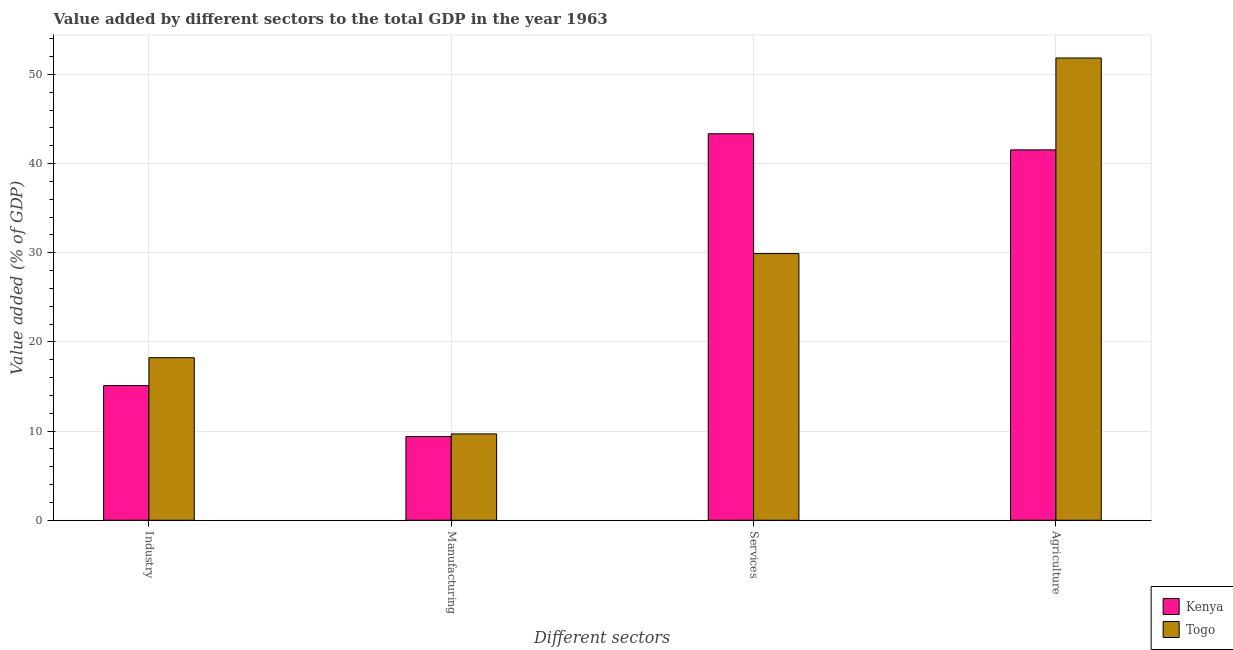Are the number of bars per tick equal to the number of legend labels?
Your answer should be compact. Yes. What is the label of the 4th group of bars from the left?
Ensure brevity in your answer.  Agriculture. What is the value added by manufacturing sector in Kenya?
Give a very brief answer. 9.39. Across all countries, what is the maximum value added by services sector?
Your answer should be very brief. 43.35. Across all countries, what is the minimum value added by industrial sector?
Your answer should be very brief. 15.1. In which country was the value added by manufacturing sector maximum?
Provide a succinct answer. Togo. In which country was the value added by industrial sector minimum?
Your answer should be very brief. Kenya. What is the total value added by services sector in the graph?
Make the answer very short. 73.27. What is the difference between the value added by services sector in Kenya and that in Togo?
Ensure brevity in your answer.  13.44. What is the difference between the value added by manufacturing sector in Kenya and the value added by services sector in Togo?
Make the answer very short. -20.52. What is the average value added by industrial sector per country?
Provide a succinct answer. 16.67. What is the difference between the value added by services sector and value added by agricultural sector in Kenya?
Give a very brief answer. 1.81. In how many countries, is the value added by services sector greater than 48 %?
Your response must be concise. 0. What is the ratio of the value added by industrial sector in Togo to that in Kenya?
Your response must be concise. 1.21. What is the difference between the highest and the second highest value added by agricultural sector?
Offer a very short reply. 10.31. What is the difference between the highest and the lowest value added by agricultural sector?
Your answer should be very brief. 10.31. Is it the case that in every country, the sum of the value added by industrial sector and value added by agricultural sector is greater than the sum of value added by services sector and value added by manufacturing sector?
Give a very brief answer. Yes. What does the 2nd bar from the left in Industry represents?
Your answer should be very brief. Togo. What does the 2nd bar from the right in Services represents?
Provide a succinct answer. Kenya. Are all the bars in the graph horizontal?
Provide a succinct answer. No. Are the values on the major ticks of Y-axis written in scientific E-notation?
Keep it short and to the point. No. Does the graph contain any zero values?
Keep it short and to the point. No. Does the graph contain grids?
Make the answer very short. Yes. How are the legend labels stacked?
Your answer should be very brief. Vertical. What is the title of the graph?
Provide a short and direct response. Value added by different sectors to the total GDP in the year 1963. Does "Peru" appear as one of the legend labels in the graph?
Provide a succinct answer. No. What is the label or title of the X-axis?
Offer a terse response. Different sectors. What is the label or title of the Y-axis?
Your answer should be very brief. Value added (% of GDP). What is the Value added (% of GDP) of Kenya in Industry?
Your response must be concise. 15.1. What is the Value added (% of GDP) of Togo in Industry?
Keep it short and to the point. 18.23. What is the Value added (% of GDP) in Kenya in Manufacturing?
Make the answer very short. 9.39. What is the Value added (% of GDP) in Togo in Manufacturing?
Your answer should be compact. 9.69. What is the Value added (% of GDP) of Kenya in Services?
Provide a short and direct response. 43.35. What is the Value added (% of GDP) of Togo in Services?
Offer a very short reply. 29.91. What is the Value added (% of GDP) of Kenya in Agriculture?
Make the answer very short. 41.54. What is the Value added (% of GDP) of Togo in Agriculture?
Ensure brevity in your answer.  51.85. Across all Different sectors, what is the maximum Value added (% of GDP) of Kenya?
Provide a short and direct response. 43.35. Across all Different sectors, what is the maximum Value added (% of GDP) of Togo?
Make the answer very short. 51.85. Across all Different sectors, what is the minimum Value added (% of GDP) of Kenya?
Your answer should be very brief. 9.39. Across all Different sectors, what is the minimum Value added (% of GDP) in Togo?
Provide a short and direct response. 9.69. What is the total Value added (% of GDP) in Kenya in the graph?
Offer a terse response. 109.39. What is the total Value added (% of GDP) in Togo in the graph?
Give a very brief answer. 109.69. What is the difference between the Value added (% of GDP) in Kenya in Industry and that in Manufacturing?
Your answer should be compact. 5.71. What is the difference between the Value added (% of GDP) in Togo in Industry and that in Manufacturing?
Your answer should be very brief. 8.55. What is the difference between the Value added (% of GDP) in Kenya in Industry and that in Services?
Your answer should be very brief. -28.25. What is the difference between the Value added (% of GDP) of Togo in Industry and that in Services?
Make the answer very short. -11.68. What is the difference between the Value added (% of GDP) in Kenya in Industry and that in Agriculture?
Keep it short and to the point. -26.44. What is the difference between the Value added (% of GDP) of Togo in Industry and that in Agriculture?
Offer a very short reply. -33.62. What is the difference between the Value added (% of GDP) of Kenya in Manufacturing and that in Services?
Your response must be concise. -33.96. What is the difference between the Value added (% of GDP) in Togo in Manufacturing and that in Services?
Provide a succinct answer. -20.23. What is the difference between the Value added (% of GDP) of Kenya in Manufacturing and that in Agriculture?
Make the answer very short. -32.15. What is the difference between the Value added (% of GDP) of Togo in Manufacturing and that in Agriculture?
Provide a short and direct response. -42.17. What is the difference between the Value added (% of GDP) of Kenya in Services and that in Agriculture?
Your answer should be compact. 1.81. What is the difference between the Value added (% of GDP) in Togo in Services and that in Agriculture?
Your answer should be compact. -21.94. What is the difference between the Value added (% of GDP) in Kenya in Industry and the Value added (% of GDP) in Togo in Manufacturing?
Offer a very short reply. 5.42. What is the difference between the Value added (% of GDP) of Kenya in Industry and the Value added (% of GDP) of Togo in Services?
Give a very brief answer. -14.81. What is the difference between the Value added (% of GDP) in Kenya in Industry and the Value added (% of GDP) in Togo in Agriculture?
Give a very brief answer. -36.75. What is the difference between the Value added (% of GDP) in Kenya in Manufacturing and the Value added (% of GDP) in Togo in Services?
Provide a succinct answer. -20.52. What is the difference between the Value added (% of GDP) of Kenya in Manufacturing and the Value added (% of GDP) of Togo in Agriculture?
Make the answer very short. -42.46. What is the difference between the Value added (% of GDP) in Kenya in Services and the Value added (% of GDP) in Togo in Agriculture?
Ensure brevity in your answer.  -8.5. What is the average Value added (% of GDP) in Kenya per Different sectors?
Your answer should be very brief. 27.35. What is the average Value added (% of GDP) of Togo per Different sectors?
Keep it short and to the point. 27.42. What is the difference between the Value added (% of GDP) in Kenya and Value added (% of GDP) in Togo in Industry?
Provide a succinct answer. -3.13. What is the difference between the Value added (% of GDP) in Kenya and Value added (% of GDP) in Togo in Manufacturing?
Your response must be concise. -0.29. What is the difference between the Value added (% of GDP) of Kenya and Value added (% of GDP) of Togo in Services?
Provide a short and direct response. 13.44. What is the difference between the Value added (% of GDP) of Kenya and Value added (% of GDP) of Togo in Agriculture?
Offer a very short reply. -10.31. What is the ratio of the Value added (% of GDP) in Kenya in Industry to that in Manufacturing?
Offer a terse response. 1.61. What is the ratio of the Value added (% of GDP) of Togo in Industry to that in Manufacturing?
Provide a succinct answer. 1.88. What is the ratio of the Value added (% of GDP) in Kenya in Industry to that in Services?
Keep it short and to the point. 0.35. What is the ratio of the Value added (% of GDP) of Togo in Industry to that in Services?
Your answer should be very brief. 0.61. What is the ratio of the Value added (% of GDP) of Kenya in Industry to that in Agriculture?
Provide a succinct answer. 0.36. What is the ratio of the Value added (% of GDP) in Togo in Industry to that in Agriculture?
Your answer should be compact. 0.35. What is the ratio of the Value added (% of GDP) of Kenya in Manufacturing to that in Services?
Your answer should be very brief. 0.22. What is the ratio of the Value added (% of GDP) of Togo in Manufacturing to that in Services?
Ensure brevity in your answer.  0.32. What is the ratio of the Value added (% of GDP) in Kenya in Manufacturing to that in Agriculture?
Your answer should be compact. 0.23. What is the ratio of the Value added (% of GDP) in Togo in Manufacturing to that in Agriculture?
Offer a terse response. 0.19. What is the ratio of the Value added (% of GDP) in Kenya in Services to that in Agriculture?
Offer a terse response. 1.04. What is the ratio of the Value added (% of GDP) in Togo in Services to that in Agriculture?
Keep it short and to the point. 0.58. What is the difference between the highest and the second highest Value added (% of GDP) in Kenya?
Your answer should be very brief. 1.81. What is the difference between the highest and the second highest Value added (% of GDP) of Togo?
Offer a terse response. 21.94. What is the difference between the highest and the lowest Value added (% of GDP) of Kenya?
Provide a succinct answer. 33.96. What is the difference between the highest and the lowest Value added (% of GDP) in Togo?
Keep it short and to the point. 42.17. 